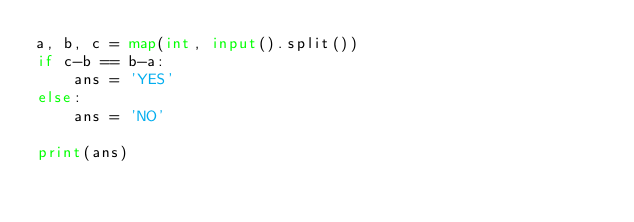<code> <loc_0><loc_0><loc_500><loc_500><_Python_>a, b, c = map(int, input().split())
if c-b == b-a:
    ans = 'YES'
else:
    ans = 'NO'

print(ans)</code> 